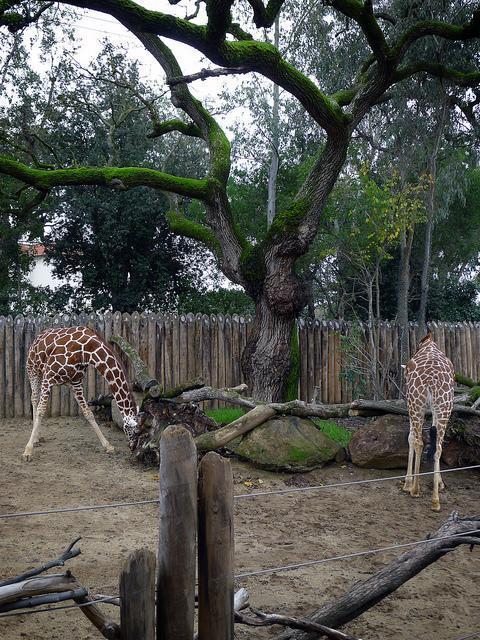How many giraffes are there?
Give a very brief answer. 2. How many people are sitting behind the fence?
Give a very brief answer. 0. 